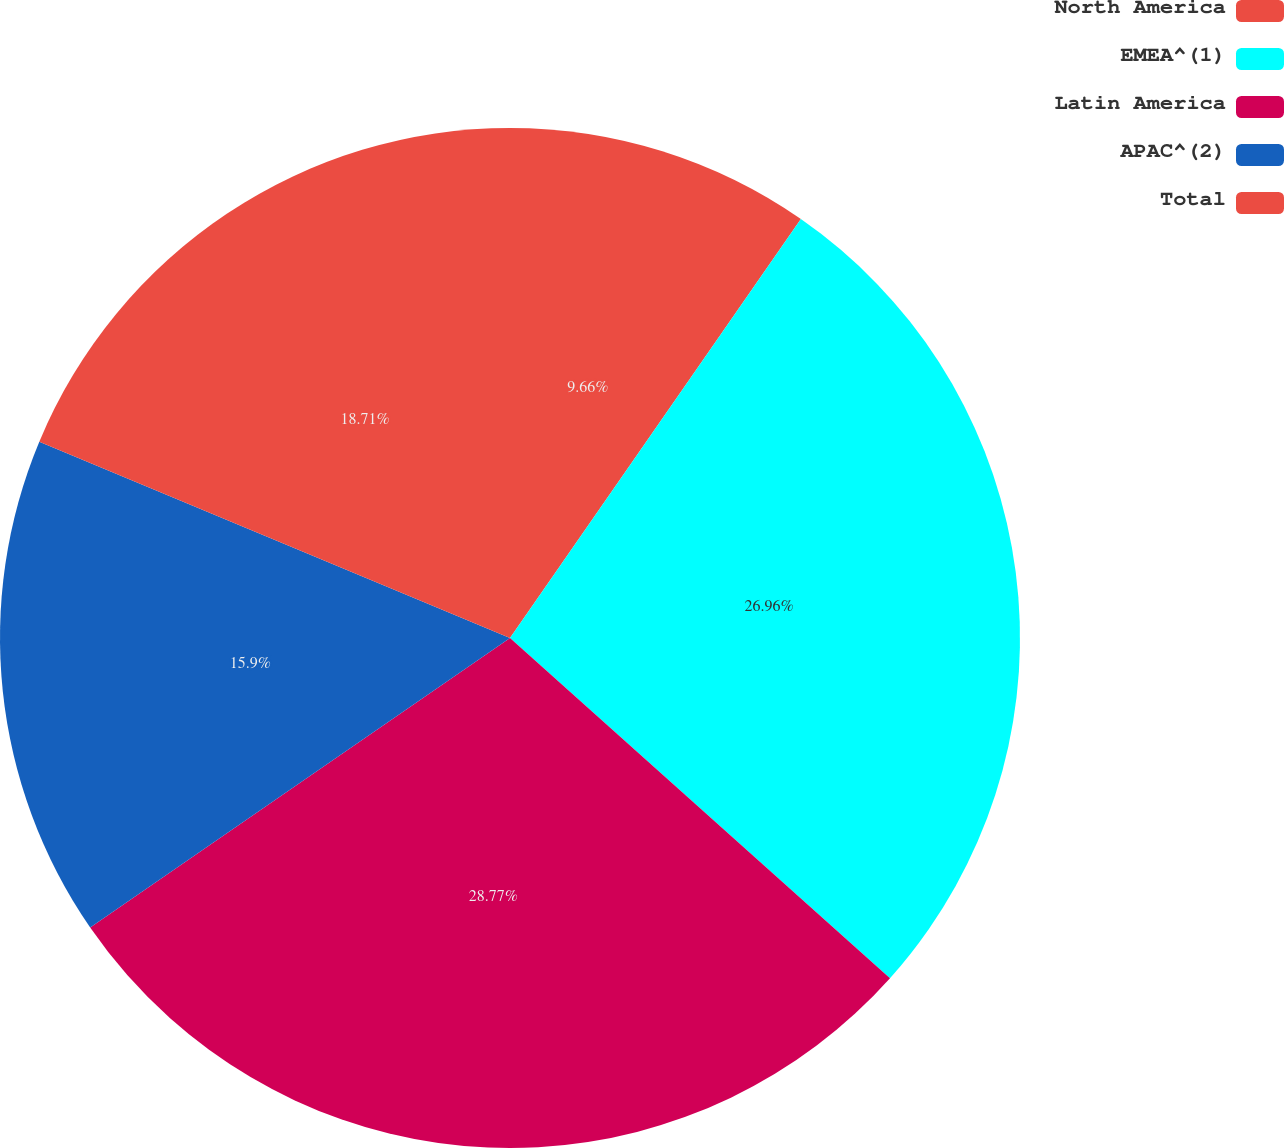<chart> <loc_0><loc_0><loc_500><loc_500><pie_chart><fcel>North America<fcel>EMEA^(1)<fcel>Latin America<fcel>APAC^(2)<fcel>Total<nl><fcel>9.66%<fcel>26.96%<fcel>28.77%<fcel>15.9%<fcel>18.71%<nl></chart> 